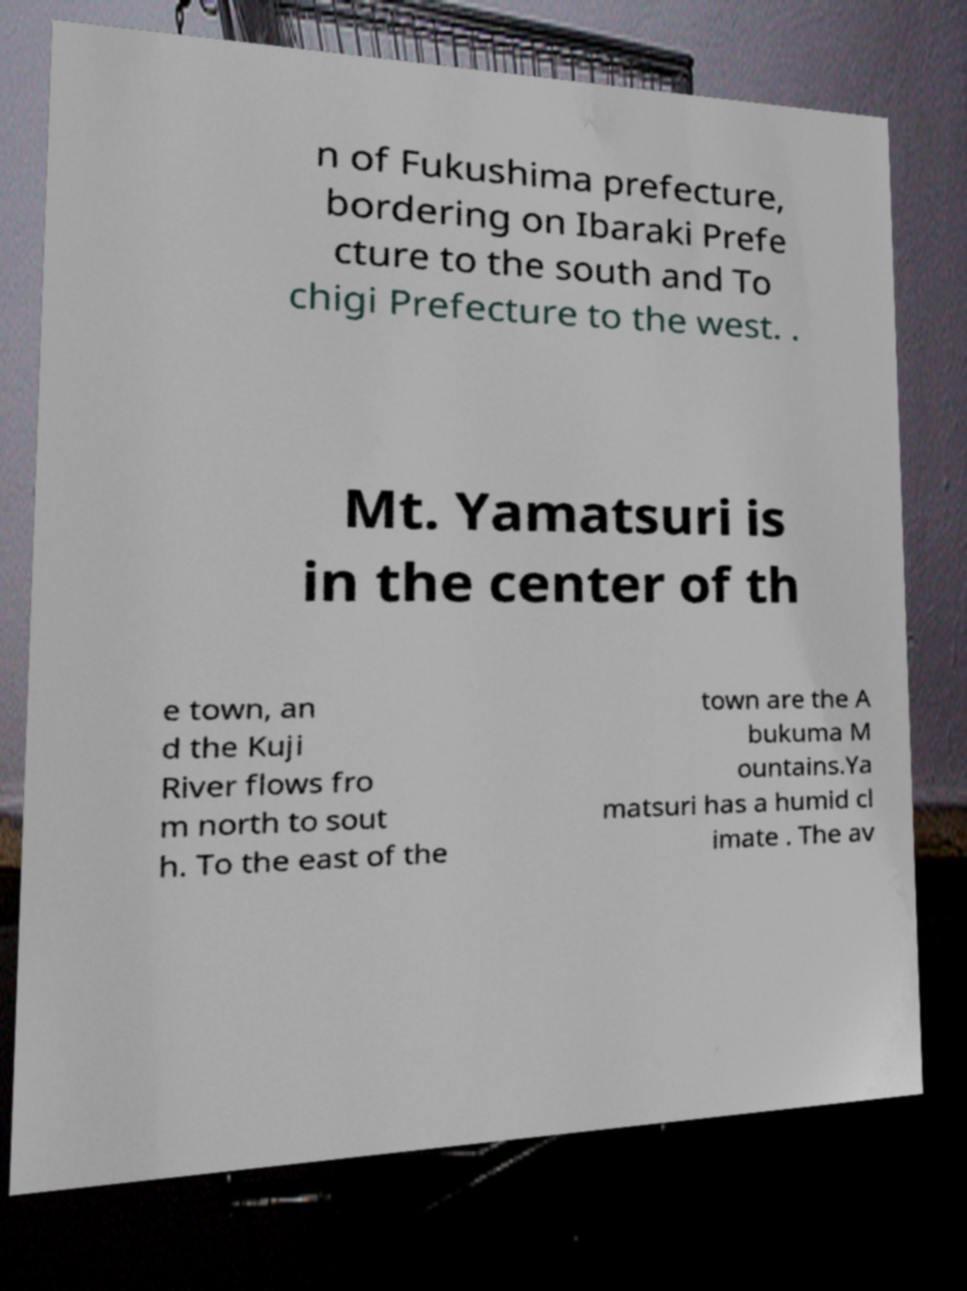For documentation purposes, I need the text within this image transcribed. Could you provide that? n of Fukushima prefecture, bordering on Ibaraki Prefe cture to the south and To chigi Prefecture to the west. . Mt. Yamatsuri is in the center of th e town, an d the Kuji River flows fro m north to sout h. To the east of the town are the A bukuma M ountains.Ya matsuri has a humid cl imate . The av 